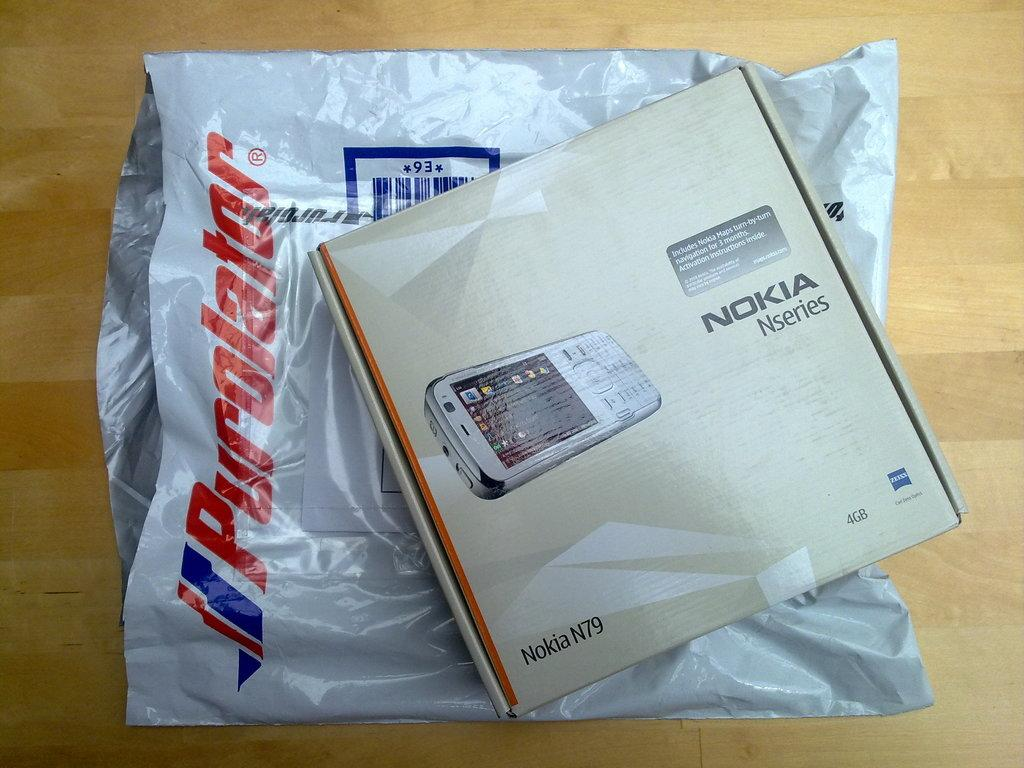<image>
Write a terse but informative summary of the picture. the word Nokia that is on some packages 